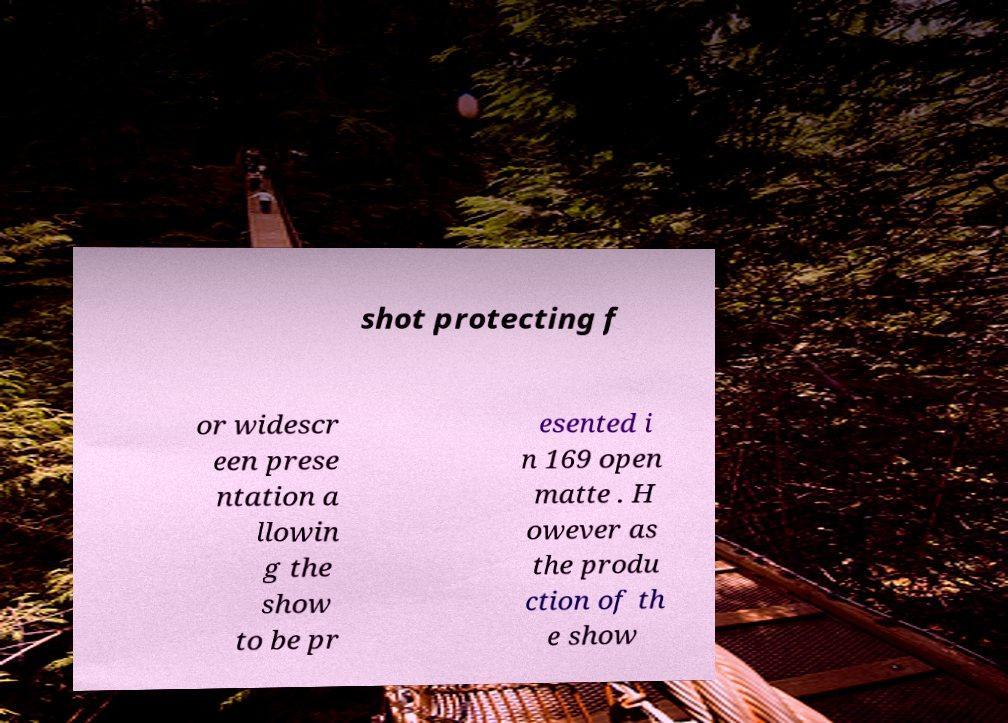Can you read and provide the text displayed in the image?This photo seems to have some interesting text. Can you extract and type it out for me? shot protecting f or widescr een prese ntation a llowin g the show to be pr esented i n 169 open matte . H owever as the produ ction of th e show 